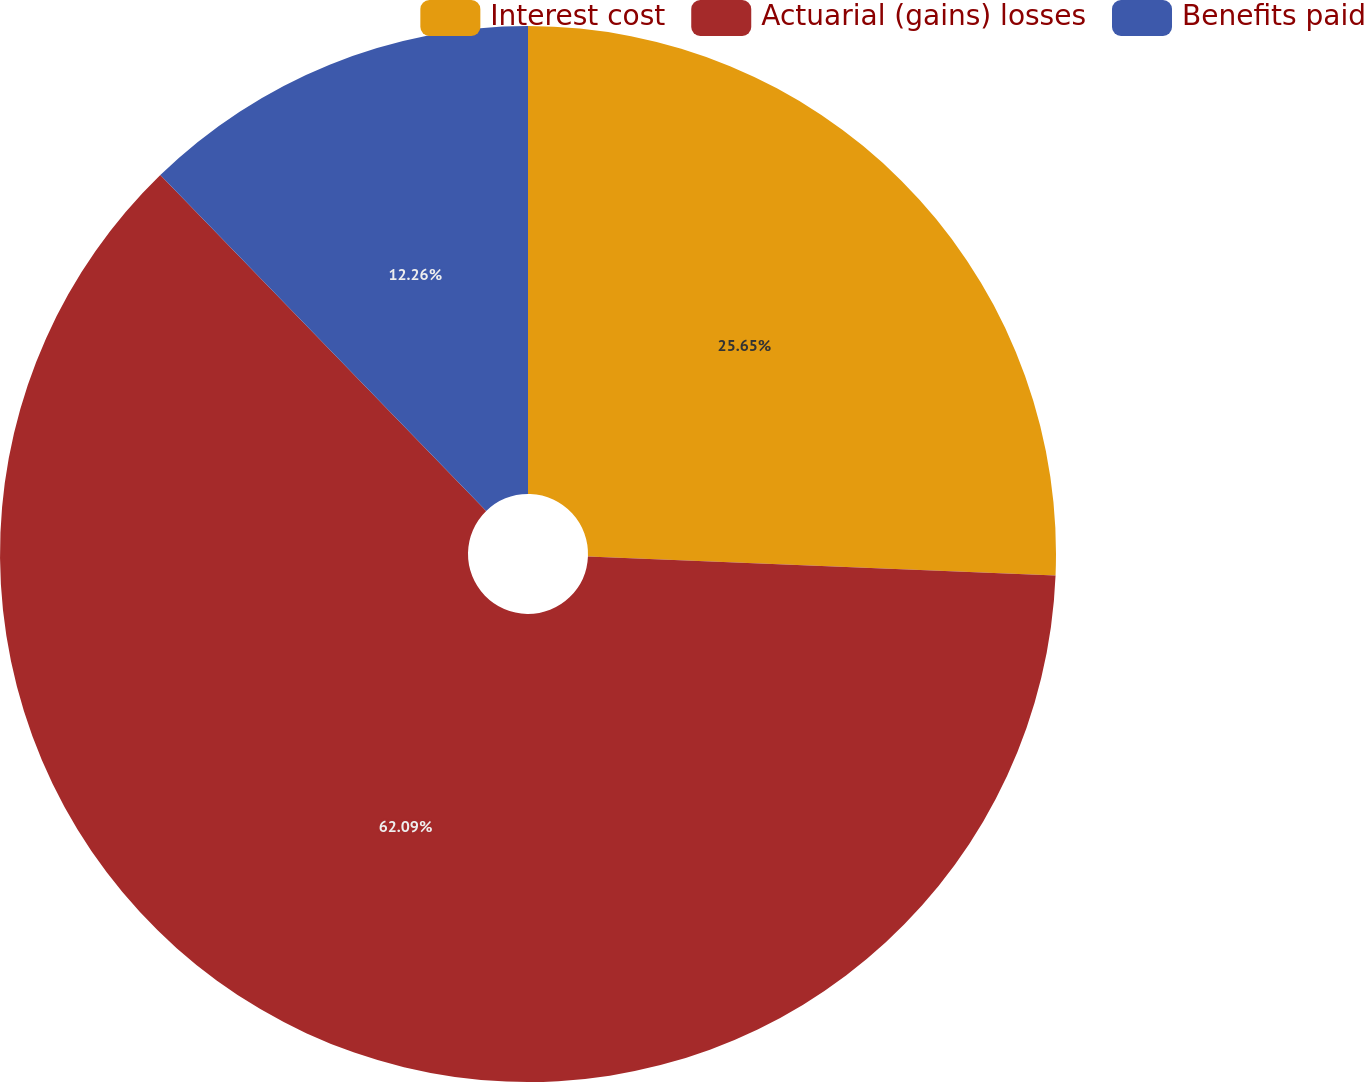Convert chart. <chart><loc_0><loc_0><loc_500><loc_500><pie_chart><fcel>Interest cost<fcel>Actuarial (gains) losses<fcel>Benefits paid<nl><fcel>25.65%<fcel>62.09%<fcel>12.26%<nl></chart> 